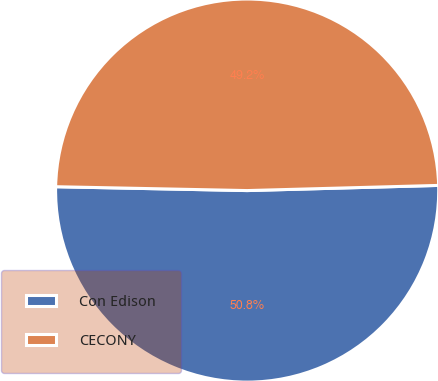Convert chart to OTSL. <chart><loc_0><loc_0><loc_500><loc_500><pie_chart><fcel>Con Edison<fcel>CECONY<nl><fcel>50.75%<fcel>49.25%<nl></chart> 